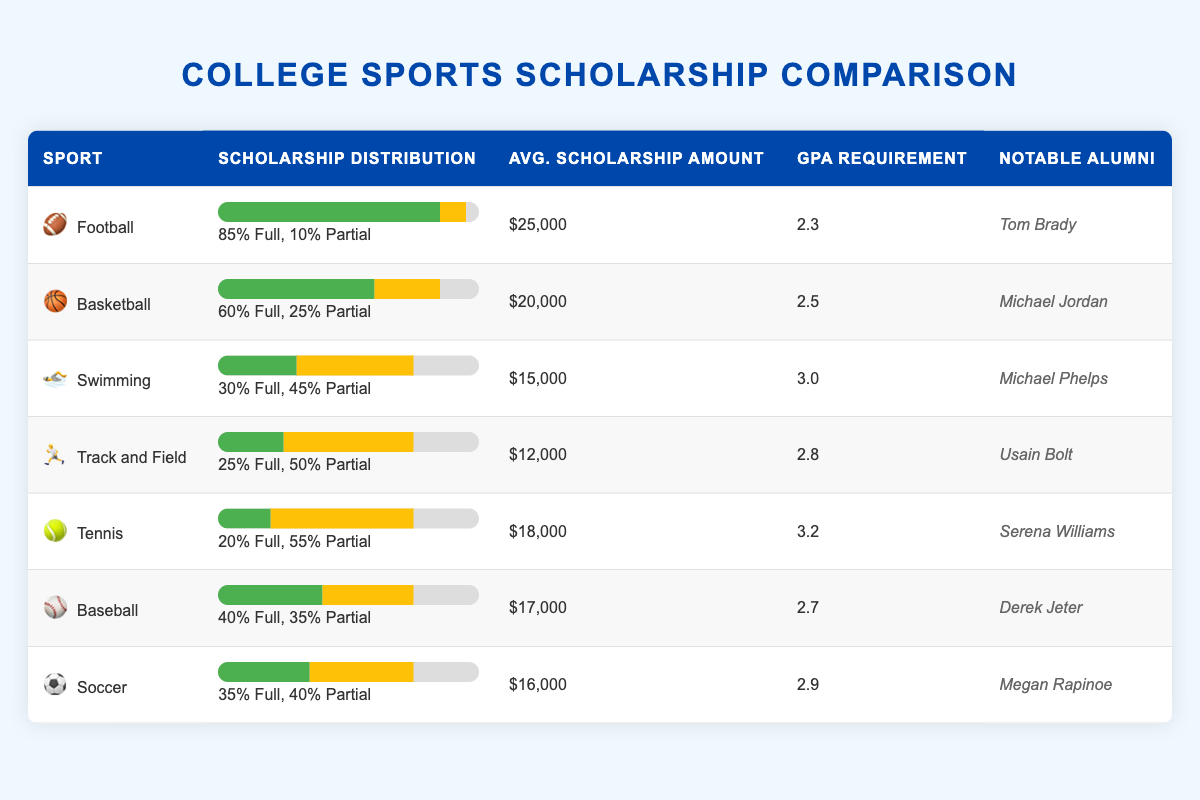What sport has the highest full scholarship percentage? The table shows Football with a full scholarship percentage of 85%, which is higher than the other sports listed.
Answer: Football Which sport has the lowest average scholarship amount? The table indicates that Track and Field has the lowest average scholarship amount of $12,000 compared to the other listed sports.
Answer: Track and Field Is it true that Swimming offers more partial scholarships than Baseball? Swimming has a partial scholarship percentage of 45%, while Baseball has a partial percentage of 35%. Therefore, it is true that Swimming offers more partial scholarships.
Answer: Yes What is the average GPA requirement for the sports listed? To calculate the average GPA requirement: (2.3 + 2.5 + 3.0 + 2.8 + 3.2 + 2.7 + 2.9) / 7 = 2.6857, rounded to two decimal places is 2.69.
Answer: 2.69 Does Tennis have a higher full scholarship percentage than Soccer? Tennis has a full scholarship percentage of 20%, while Soccer has a full scholarship percentage of 35%. Since 20% is less than 35%, it is not true that Tennis has a higher full scholarship percentage.
Answer: No Which sport has the same percentage of partial scholarships as Track and Field? Track and Field has a partial scholarship percentage of 50%. Looking through the table, Track and Field shares this percentage with no other sport; hence, no sport has this same percentage.
Answer: None What is the difference in average scholarship amounts between Football and Swimming? The average scholarship amount for Football is $25,000, while for Swimming, it is $15,000. The difference is calculated as 25,000 - 15,000 = 10,000.
Answer: $10,000 Which notable alumni are associated with the sport that offers the most full scholarships? The sport with the most full scholarships is Football, which is associated with the notable alumni Tom Brady.
Answer: Tom Brady 